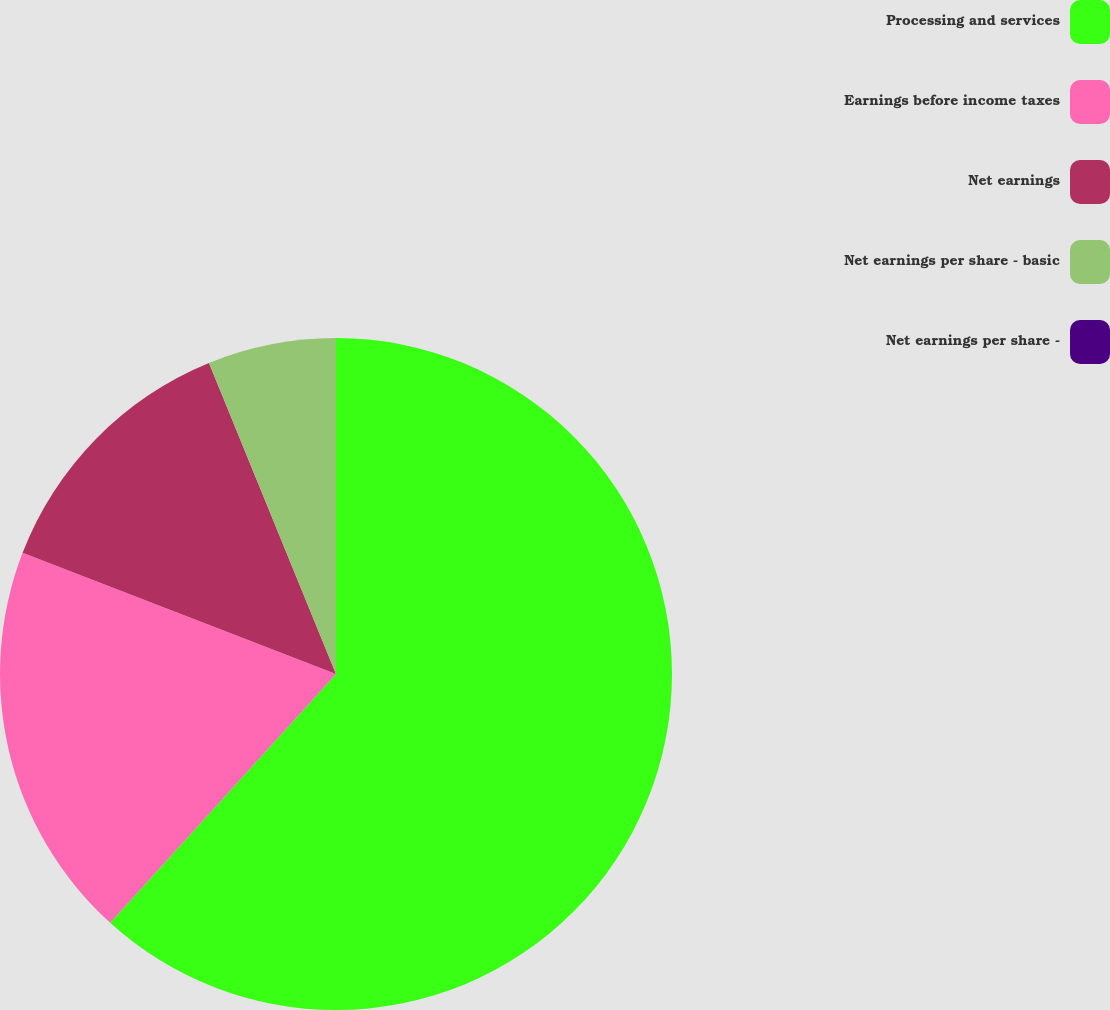<chart> <loc_0><loc_0><loc_500><loc_500><pie_chart><fcel>Processing and services<fcel>Earnings before income taxes<fcel>Net earnings<fcel>Net earnings per share - basic<fcel>Net earnings per share -<nl><fcel>61.73%<fcel>19.14%<fcel>12.96%<fcel>6.17%<fcel>0.0%<nl></chart> 